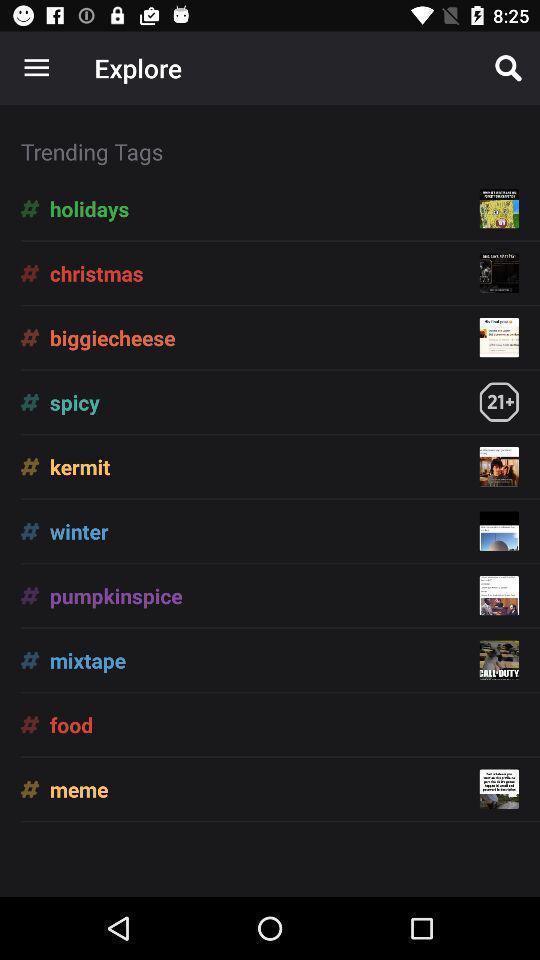Give me a narrative description of this picture. Screen displaying list of trending tags. 